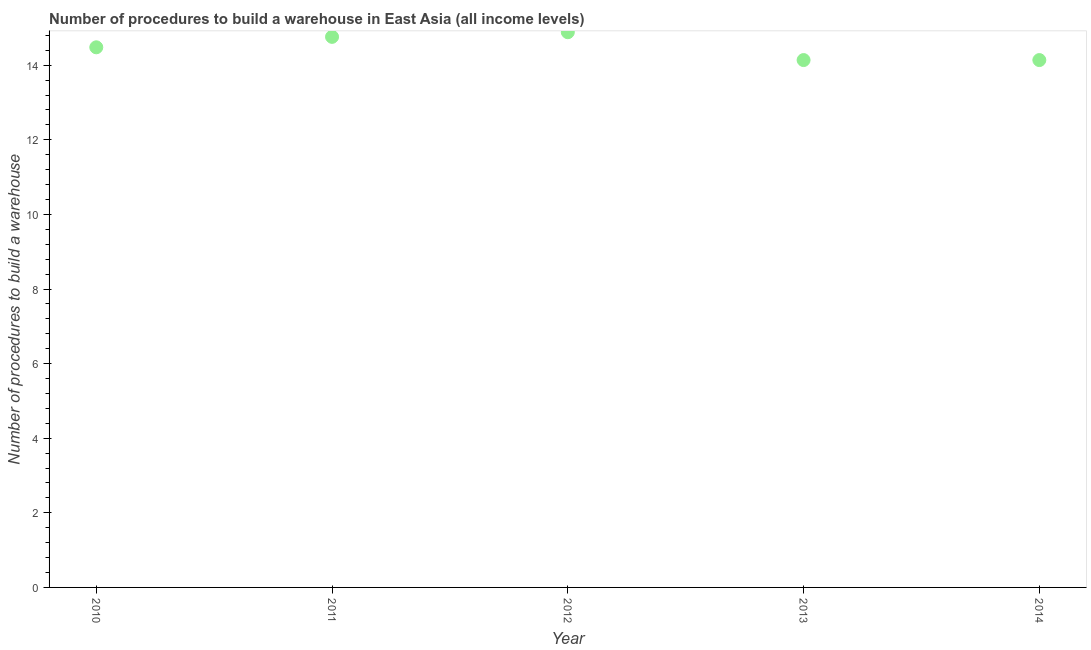What is the number of procedures to build a warehouse in 2013?
Provide a succinct answer. 14.14. Across all years, what is the maximum number of procedures to build a warehouse?
Provide a short and direct response. 14.88. Across all years, what is the minimum number of procedures to build a warehouse?
Your answer should be very brief. 14.14. In which year was the number of procedures to build a warehouse maximum?
Your answer should be very brief. 2012. What is the sum of the number of procedures to build a warehouse?
Your answer should be compact. 72.4. What is the difference between the number of procedures to build a warehouse in 2010 and 2012?
Offer a very short reply. -0.4. What is the average number of procedures to build a warehouse per year?
Your response must be concise. 14.48. What is the median number of procedures to build a warehouse?
Offer a terse response. 14.48. In how many years, is the number of procedures to build a warehouse greater than 6.4 ?
Keep it short and to the point. 5. What is the ratio of the number of procedures to build a warehouse in 2011 to that in 2012?
Give a very brief answer. 0.99. What is the difference between the highest and the second highest number of procedures to build a warehouse?
Provide a succinct answer. 0.12. What is the difference between the highest and the lowest number of procedures to build a warehouse?
Provide a short and direct response. 0.75. How many dotlines are there?
Ensure brevity in your answer.  1. How many years are there in the graph?
Your answer should be very brief. 5. Does the graph contain grids?
Your response must be concise. No. What is the title of the graph?
Your answer should be compact. Number of procedures to build a warehouse in East Asia (all income levels). What is the label or title of the Y-axis?
Ensure brevity in your answer.  Number of procedures to build a warehouse. What is the Number of procedures to build a warehouse in 2010?
Make the answer very short. 14.48. What is the Number of procedures to build a warehouse in 2011?
Make the answer very short. 14.76. What is the Number of procedures to build a warehouse in 2012?
Offer a terse response. 14.88. What is the Number of procedures to build a warehouse in 2013?
Keep it short and to the point. 14.14. What is the Number of procedures to build a warehouse in 2014?
Make the answer very short. 14.14. What is the difference between the Number of procedures to build a warehouse in 2010 and 2011?
Your answer should be compact. -0.28. What is the difference between the Number of procedures to build a warehouse in 2010 and 2012?
Offer a terse response. -0.4. What is the difference between the Number of procedures to build a warehouse in 2010 and 2013?
Keep it short and to the point. 0.34. What is the difference between the Number of procedures to build a warehouse in 2010 and 2014?
Offer a very short reply. 0.34. What is the difference between the Number of procedures to build a warehouse in 2011 and 2012?
Offer a very short reply. -0.12. What is the difference between the Number of procedures to build a warehouse in 2011 and 2013?
Offer a terse response. 0.62. What is the difference between the Number of procedures to build a warehouse in 2011 and 2014?
Your response must be concise. 0.62. What is the difference between the Number of procedures to build a warehouse in 2012 and 2013?
Your answer should be very brief. 0.75. What is the difference between the Number of procedures to build a warehouse in 2012 and 2014?
Make the answer very short. 0.75. What is the ratio of the Number of procedures to build a warehouse in 2010 to that in 2012?
Make the answer very short. 0.97. What is the ratio of the Number of procedures to build a warehouse in 2010 to that in 2013?
Offer a very short reply. 1.02. What is the ratio of the Number of procedures to build a warehouse in 2011 to that in 2013?
Ensure brevity in your answer.  1.04. What is the ratio of the Number of procedures to build a warehouse in 2011 to that in 2014?
Ensure brevity in your answer.  1.04. What is the ratio of the Number of procedures to build a warehouse in 2012 to that in 2013?
Provide a short and direct response. 1.05. What is the ratio of the Number of procedures to build a warehouse in 2012 to that in 2014?
Ensure brevity in your answer.  1.05. What is the ratio of the Number of procedures to build a warehouse in 2013 to that in 2014?
Give a very brief answer. 1. 